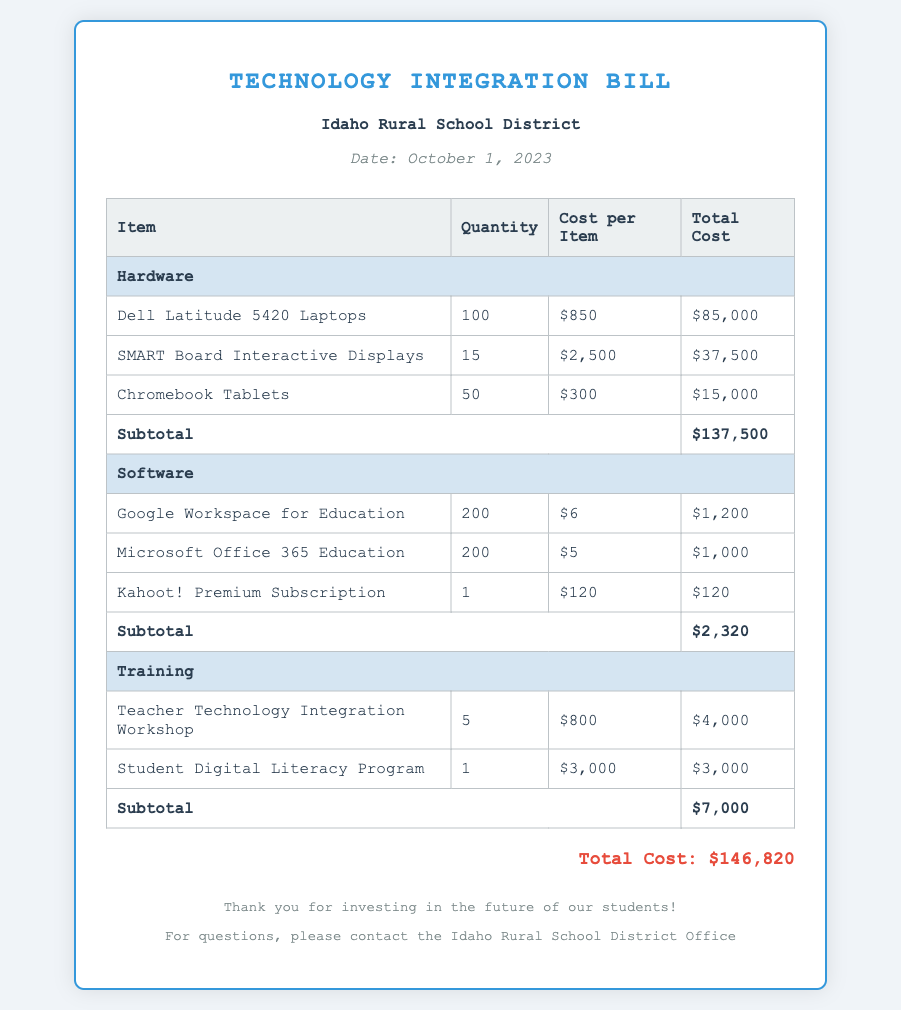What is the total cost? The total cost is listed at the bottom of the document, summing all expenses for hardware, software, and training.
Answer: $146,820 How many Dell Latitude 5420 Laptops are included? The document specifies the quantity of Dell Latitude 5420 Laptops under the hardware section.
Answer: 100 What is the cost of the Student Digital Literacy Program? The cost for the Student Digital Literacy Program is detailed under the training section.
Answer: $3,000 How much is allocated for software in total? The software costs are subtotaled, allowing easy calculation of the total software cost.
Answer: $2,320 Which training program has the highest cost? By comparing the costs of the training programs listed, one can identify the one with the highest expenditure.
Answer: Student Digital Literacy Program What is the quantity of SMART Board Interactive Displays? The document indicates the number of SMART Board Interactive Displays listed under hardware.
Answer: 15 What is the total cost for hardware? The total for hardware is provided as a subtotal in the document, summarizing all hardware costs.
Answer: $137,500 When was the Technology Integration Bill dated? The date of the bill is clearly stated in the header section of the document.
Answer: October 1, 2023 Who to contact for questions regarding the bill? The footer section of the document provides contact information for inquiries related to the bill.
Answer: Idaho Rural School District Office 